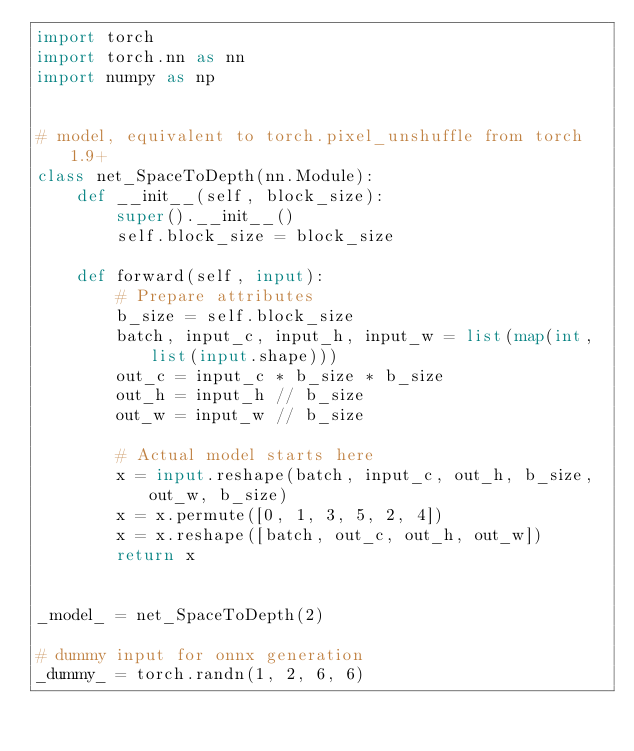<code> <loc_0><loc_0><loc_500><loc_500><_Python_>import torch
import torch.nn as nn
import numpy as np


# model, equivalent to torch.pixel_unshuffle from torch 1.9+
class net_SpaceToDepth(nn.Module):
    def __init__(self, block_size):
        super().__init__()
        self.block_size = block_size

    def forward(self, input):
        # Prepare attributes
        b_size = self.block_size
        batch, input_c, input_h, input_w = list(map(int, list(input.shape)))
        out_c = input_c * b_size * b_size
        out_h = input_h // b_size
        out_w = input_w // b_size

        # Actual model starts here
        x = input.reshape(batch, input_c, out_h, b_size, out_w, b_size)
        x = x.permute([0, 1, 3, 5, 2, 4])
        x = x.reshape([batch, out_c, out_h, out_w])
        return x


_model_ = net_SpaceToDepth(2)

# dummy input for onnx generation
_dummy_ = torch.randn(1, 2, 6, 6)
</code> 